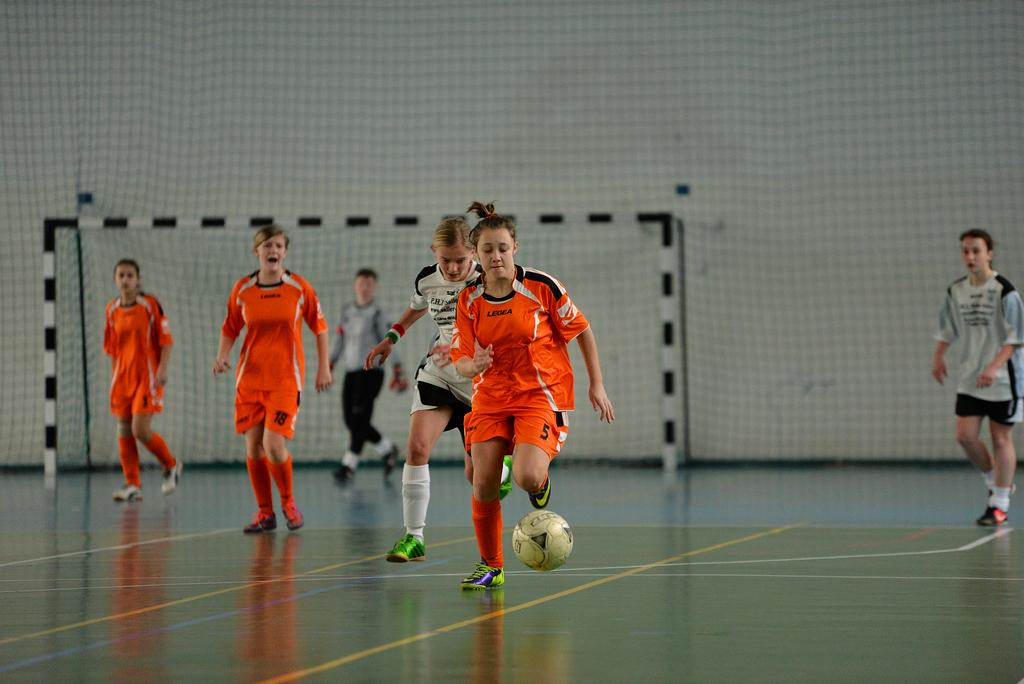What activity are the girls in the image participating in? The girls are playing football in the image. What can be seen in the background of the image? There is a goalpost and a wall in the background of the image. Where is the scarecrow located in the image? There is no scarecrow present in the image. What type of monkey can be seen climbing the wall in the image? There is no monkey present in the image; it only features girls playing football and a wall in the background. 